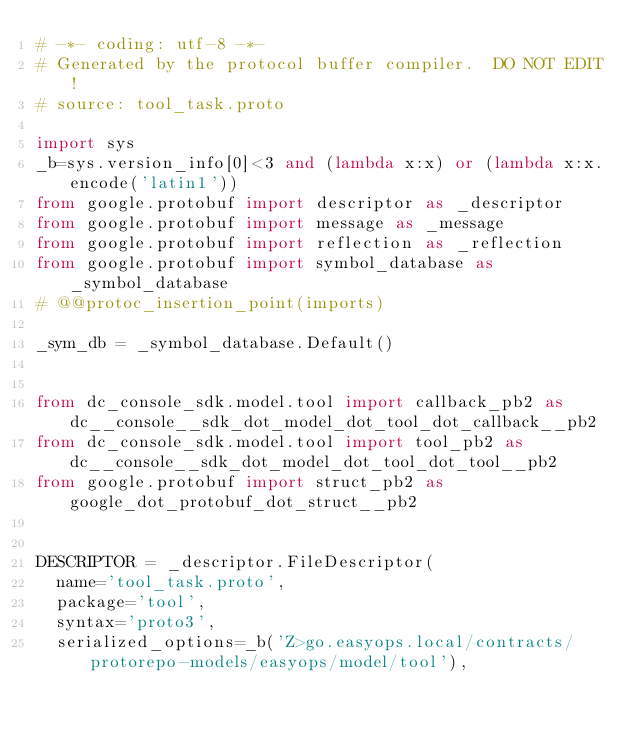Convert code to text. <code><loc_0><loc_0><loc_500><loc_500><_Python_># -*- coding: utf-8 -*-
# Generated by the protocol buffer compiler.  DO NOT EDIT!
# source: tool_task.proto

import sys
_b=sys.version_info[0]<3 and (lambda x:x) or (lambda x:x.encode('latin1'))
from google.protobuf import descriptor as _descriptor
from google.protobuf import message as _message
from google.protobuf import reflection as _reflection
from google.protobuf import symbol_database as _symbol_database
# @@protoc_insertion_point(imports)

_sym_db = _symbol_database.Default()


from dc_console_sdk.model.tool import callback_pb2 as dc__console__sdk_dot_model_dot_tool_dot_callback__pb2
from dc_console_sdk.model.tool import tool_pb2 as dc__console__sdk_dot_model_dot_tool_dot_tool__pb2
from google.protobuf import struct_pb2 as google_dot_protobuf_dot_struct__pb2


DESCRIPTOR = _descriptor.FileDescriptor(
  name='tool_task.proto',
  package='tool',
  syntax='proto3',
  serialized_options=_b('Z>go.easyops.local/contracts/protorepo-models/easyops/model/tool'),</code> 